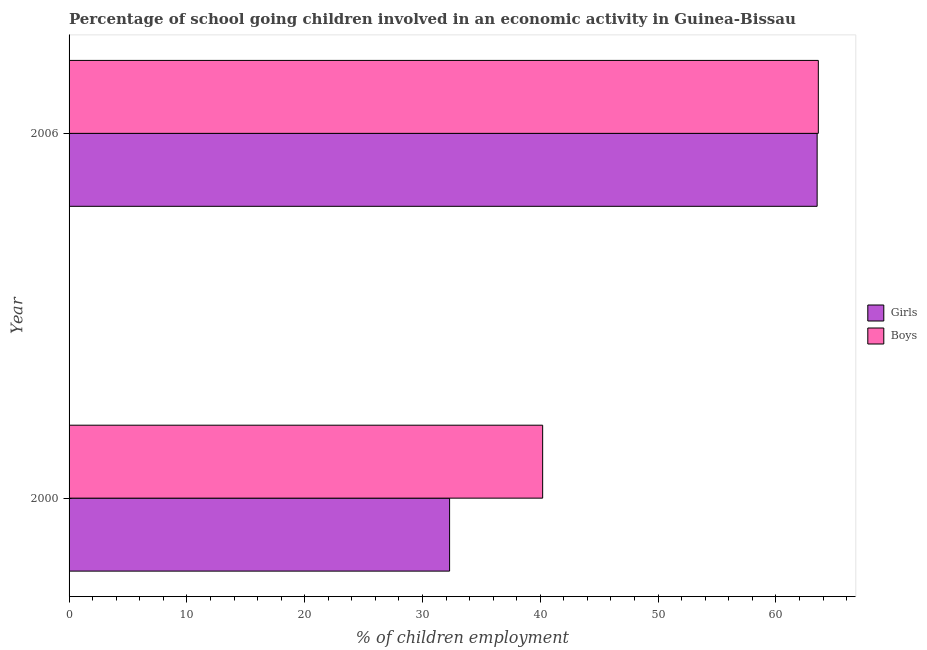How many different coloured bars are there?
Offer a very short reply. 2. How many bars are there on the 2nd tick from the top?
Your answer should be compact. 2. How many bars are there on the 2nd tick from the bottom?
Your response must be concise. 2. What is the label of the 1st group of bars from the top?
Keep it short and to the point. 2006. What is the percentage of school going girls in 2000?
Ensure brevity in your answer.  32.3. Across all years, what is the maximum percentage of school going girls?
Keep it short and to the point. 63.5. Across all years, what is the minimum percentage of school going boys?
Your answer should be very brief. 40.2. In which year was the percentage of school going girls minimum?
Offer a terse response. 2000. What is the total percentage of school going girls in the graph?
Make the answer very short. 95.8. What is the difference between the percentage of school going girls in 2000 and that in 2006?
Provide a short and direct response. -31.2. What is the difference between the percentage of school going boys in 2000 and the percentage of school going girls in 2006?
Offer a terse response. -23.3. What is the average percentage of school going boys per year?
Your response must be concise. 51.9. In how many years, is the percentage of school going boys greater than 12 %?
Keep it short and to the point. 2. What is the ratio of the percentage of school going girls in 2000 to that in 2006?
Offer a terse response. 0.51. Is the difference between the percentage of school going boys in 2000 and 2006 greater than the difference between the percentage of school going girls in 2000 and 2006?
Provide a short and direct response. Yes. In how many years, is the percentage of school going boys greater than the average percentage of school going boys taken over all years?
Offer a terse response. 1. What does the 2nd bar from the top in 2000 represents?
Give a very brief answer. Girls. What does the 2nd bar from the bottom in 2000 represents?
Ensure brevity in your answer.  Boys. How many bars are there?
Your response must be concise. 4. Are all the bars in the graph horizontal?
Your answer should be compact. Yes. What is the difference between two consecutive major ticks on the X-axis?
Offer a very short reply. 10. Are the values on the major ticks of X-axis written in scientific E-notation?
Provide a succinct answer. No. Does the graph contain grids?
Your answer should be compact. No. How are the legend labels stacked?
Your response must be concise. Vertical. What is the title of the graph?
Give a very brief answer. Percentage of school going children involved in an economic activity in Guinea-Bissau. What is the label or title of the X-axis?
Provide a succinct answer. % of children employment. What is the % of children employment of Girls in 2000?
Your response must be concise. 32.3. What is the % of children employment of Boys in 2000?
Your response must be concise. 40.2. What is the % of children employment in Girls in 2006?
Provide a succinct answer. 63.5. What is the % of children employment in Boys in 2006?
Provide a short and direct response. 63.6. Across all years, what is the maximum % of children employment in Girls?
Give a very brief answer. 63.5. Across all years, what is the maximum % of children employment in Boys?
Your response must be concise. 63.6. Across all years, what is the minimum % of children employment in Girls?
Your response must be concise. 32.3. Across all years, what is the minimum % of children employment in Boys?
Offer a terse response. 40.2. What is the total % of children employment of Girls in the graph?
Provide a short and direct response. 95.8. What is the total % of children employment in Boys in the graph?
Keep it short and to the point. 103.8. What is the difference between the % of children employment of Girls in 2000 and that in 2006?
Ensure brevity in your answer.  -31.2. What is the difference between the % of children employment in Boys in 2000 and that in 2006?
Your answer should be compact. -23.4. What is the difference between the % of children employment of Girls in 2000 and the % of children employment of Boys in 2006?
Provide a succinct answer. -31.3. What is the average % of children employment in Girls per year?
Keep it short and to the point. 47.9. What is the average % of children employment of Boys per year?
Make the answer very short. 51.9. In the year 2000, what is the difference between the % of children employment of Girls and % of children employment of Boys?
Your answer should be very brief. -7.9. In the year 2006, what is the difference between the % of children employment in Girls and % of children employment in Boys?
Make the answer very short. -0.1. What is the ratio of the % of children employment of Girls in 2000 to that in 2006?
Give a very brief answer. 0.51. What is the ratio of the % of children employment of Boys in 2000 to that in 2006?
Offer a terse response. 0.63. What is the difference between the highest and the second highest % of children employment of Girls?
Keep it short and to the point. 31.2. What is the difference between the highest and the second highest % of children employment in Boys?
Give a very brief answer. 23.4. What is the difference between the highest and the lowest % of children employment of Girls?
Provide a short and direct response. 31.2. What is the difference between the highest and the lowest % of children employment in Boys?
Provide a succinct answer. 23.4. 